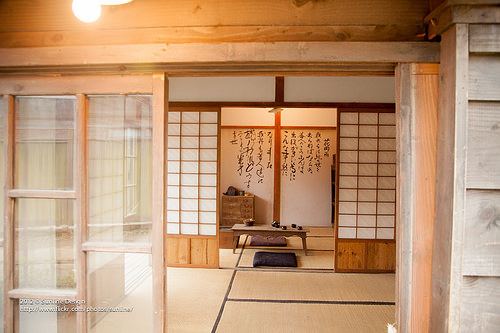<image>
Is there a table under the pillow? No. The table is not positioned under the pillow. The vertical relationship between these objects is different. 